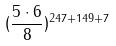Convert formula to latex. <formula><loc_0><loc_0><loc_500><loc_500>( \frac { 5 \cdot 6 } { 8 } ) ^ { 2 4 7 + 1 4 9 + 7 }</formula> 